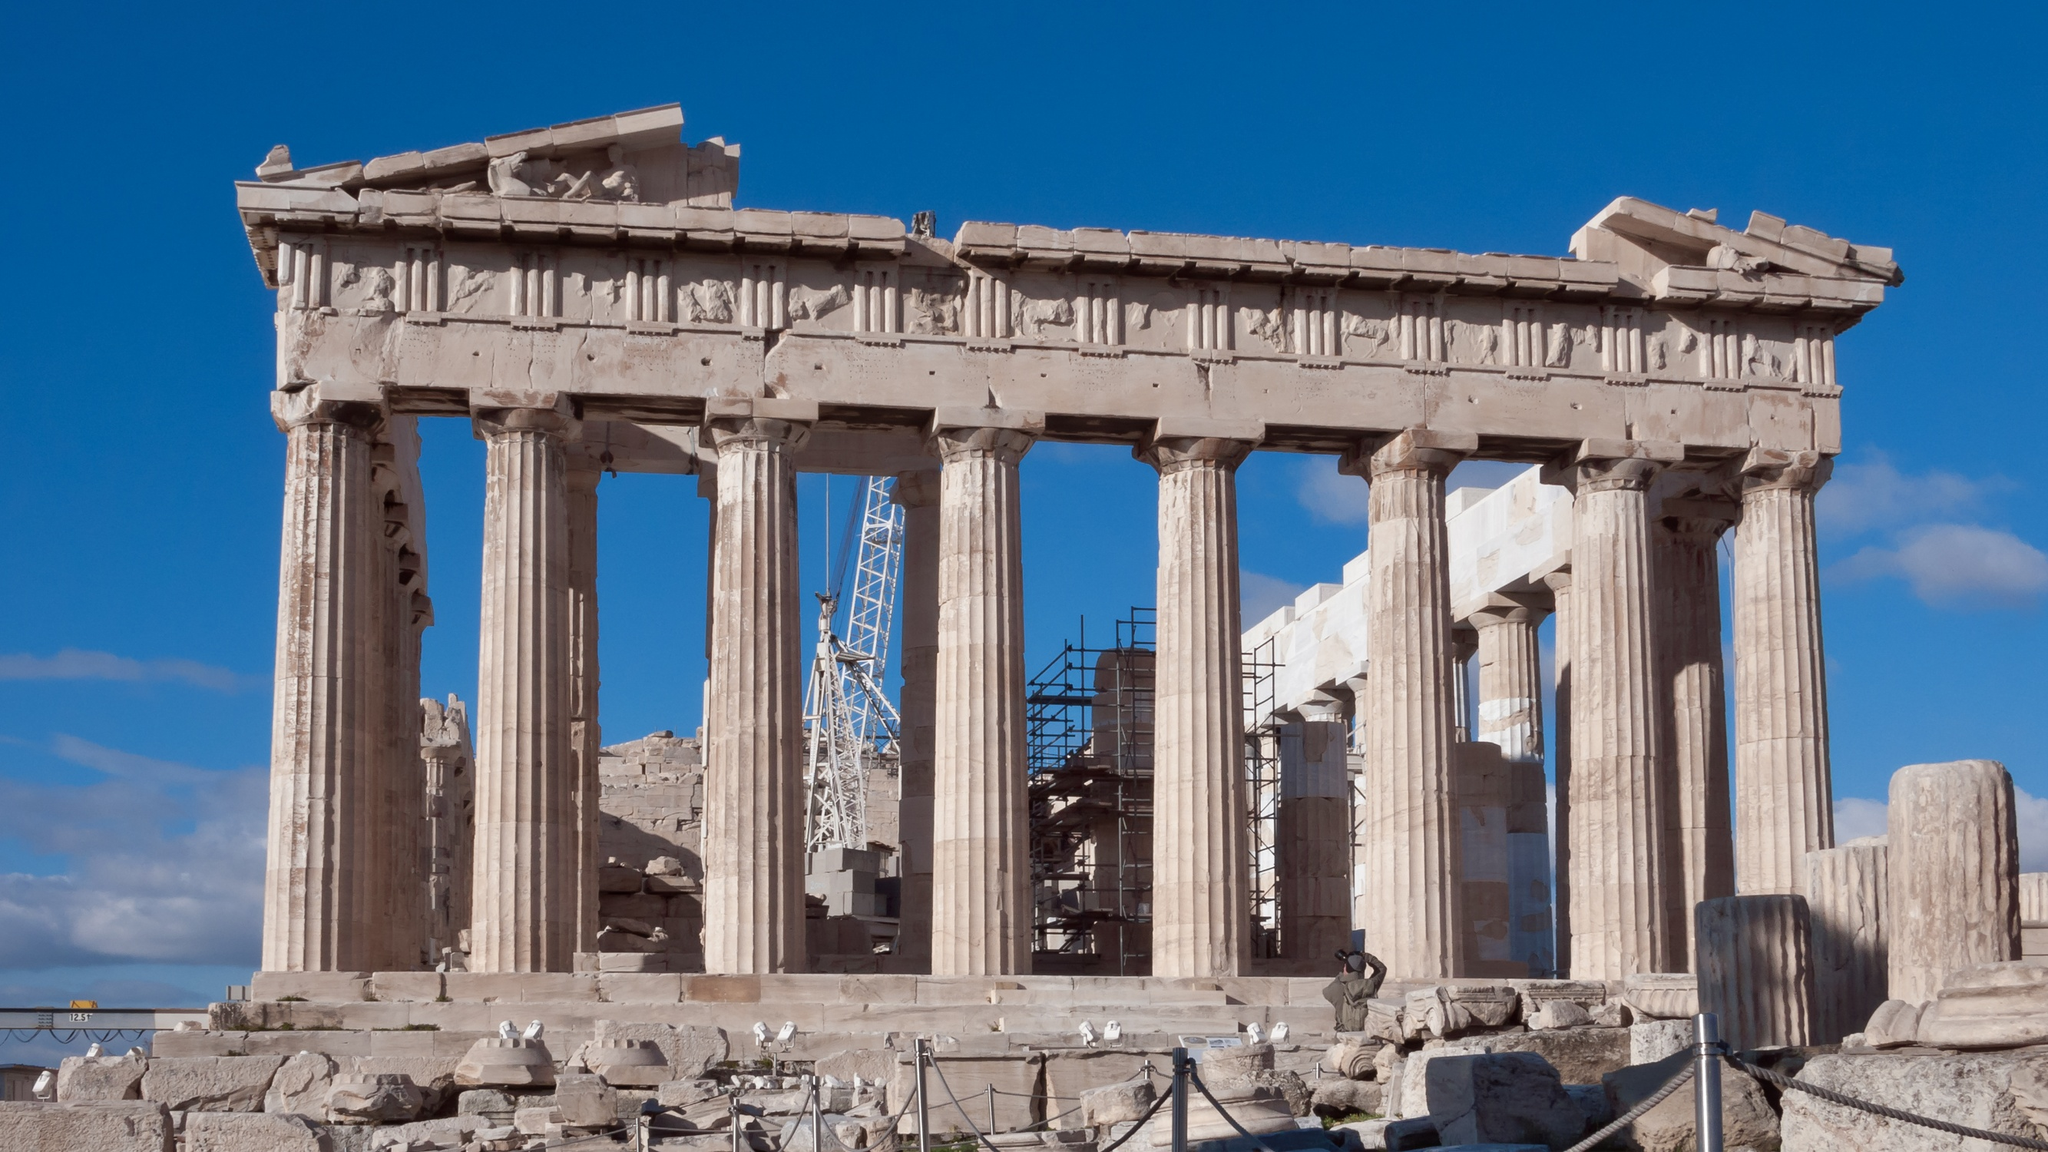What's happening in the scene? The image illustrates the iconic Parthenon, a pinnacle of ancient Greek architecture, perched atop the Athenian Acropolis in Greece. The temple is captured in full daylight, with sunlight from the left, accentuating its Doric columns and the intricate carvings of its frieze. Notably, the Parthenon is undergoing restoration, evidenced by the scaffolding and crane visible in the scene, which are part of efforts to preserve and stabilize this historic edifice. This ongoing conservation project speaks to the cultural and historical value ascribed to the Parthenon, reflecting its significance in the world's architectural heritage. 